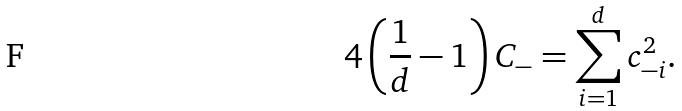Convert formula to latex. <formula><loc_0><loc_0><loc_500><loc_500>4 \left ( \frac { 1 } { d } - 1 \right ) C _ { - } = \sum _ { i = 1 } ^ { d } c _ { - i } ^ { 2 } .</formula> 